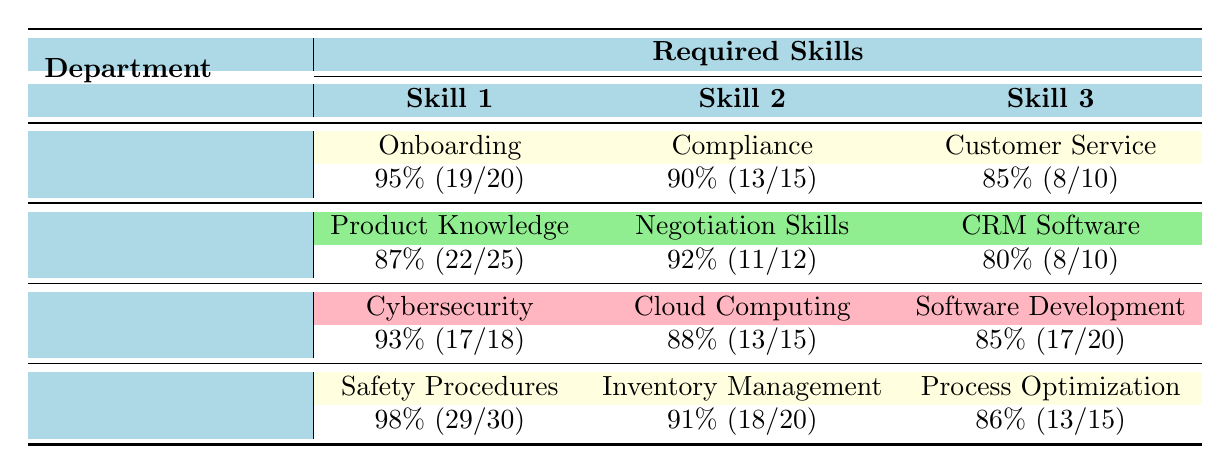What's the completion rate for Safety Procedures in the Operations department? The completion rate is provided directly in the table for the Safety Procedures under the Operations department, which shows 98%.
Answer: 98% Which skill in the Sales department has the highest completion rate? By comparing the completion rates for Product Knowledge (87%), Negotiation Skills (92%), and CRM Software (80%) listed in the Sales department, Negotiation Skills has the highest completion rate at 92%.
Answer: 92% What is the total number of required skills for the IT department? The IT department has three required skills: Cybersecurity, Cloud Computing, and Software Development. Therefore, the total number of required skills is 3.
Answer: 3 Calculate the average completion rate for Human Resources. The completion rates for Human Resources' skills are 95%, 90%, and 85%. To find the average, we sum these rates (95 + 90 + 85 = 270) and then divide by the number of skills (270/3 = 90). Hence, the average completion rate for Human Resources is 90%.
Answer: 90% Is there a skill in the IT department with a completion rate below 85%? Reviewing the completion rates for the IT department, we have Cybersecurity (93%), Cloud Computing (88%), and Software Development (85%). None of these skills have a completion rate below 85%, so the answer is no.
Answer: No Which department had the second highest total required skills? The Operations department has 3 required skills, while Human Resources has 3, Sales has 3, and IT has 3. Since all departments have the same count, we look for the department with the second highest completion rate; that would be Sales, with an average of 86.33%.
Answer: Sales What is the difference in completion rates between Inventory Management and Cloud Computing skills? The completion rate for Inventory Management in Operations is 91%, and for Cloud Computing in IT, it is 88%. The difference is calculated by subtracting Cloud Computing's rate from Inventory Management's (91 - 88 = 3).
Answer: 3 Which department has the lowest single skill completion rate and what is it? The skills listed for each department are Customer Service (85%), CRM Software (80%), Cloud Computing (88%), and Process Optimization (86%). The lowest single skill completion rate is CRM Software in the Sales department at 80%.
Answer: 80% 